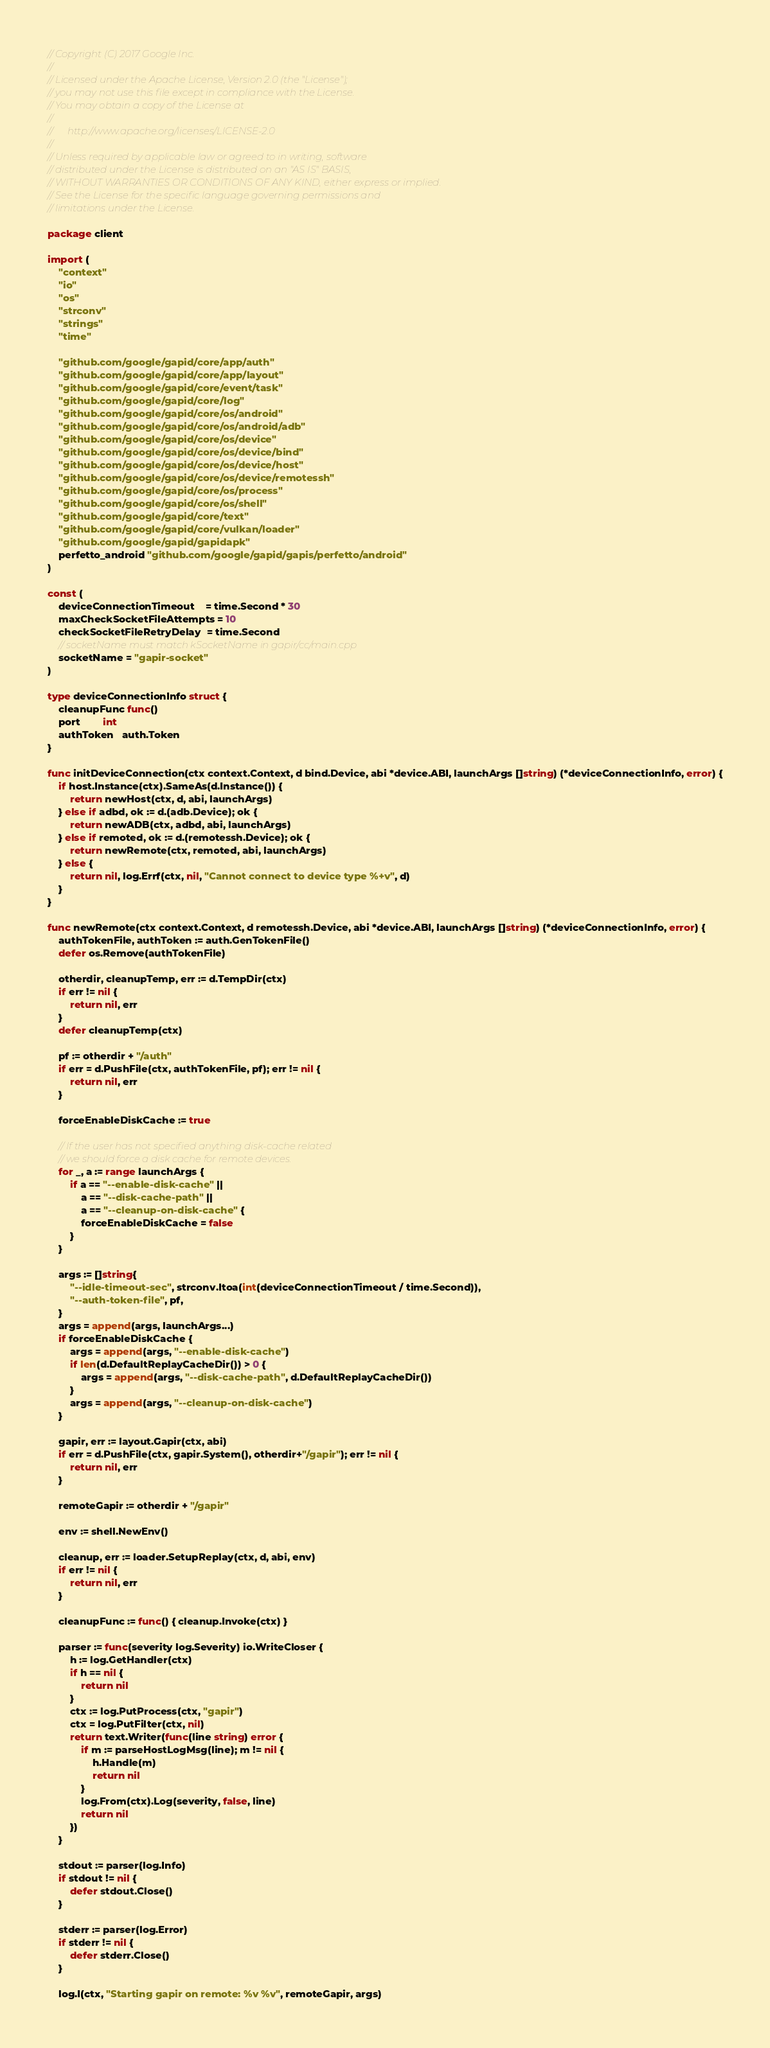<code> <loc_0><loc_0><loc_500><loc_500><_Go_>// Copyright (C) 2017 Google Inc.
//
// Licensed under the Apache License, Version 2.0 (the "License");
// you may not use this file except in compliance with the License.
// You may obtain a copy of the License at
//
//      http://www.apache.org/licenses/LICENSE-2.0
//
// Unless required by applicable law or agreed to in writing, software
// distributed under the License is distributed on an "AS IS" BASIS,
// WITHOUT WARRANTIES OR CONDITIONS OF ANY KIND, either express or implied.
// See the License for the specific language governing permissions and
// limitations under the License.

package client

import (
	"context"
	"io"
	"os"
	"strconv"
	"strings"
	"time"

	"github.com/google/gapid/core/app/auth"
	"github.com/google/gapid/core/app/layout"
	"github.com/google/gapid/core/event/task"
	"github.com/google/gapid/core/log"
	"github.com/google/gapid/core/os/android"
	"github.com/google/gapid/core/os/android/adb"
	"github.com/google/gapid/core/os/device"
	"github.com/google/gapid/core/os/device/bind"
	"github.com/google/gapid/core/os/device/host"
	"github.com/google/gapid/core/os/device/remotessh"
	"github.com/google/gapid/core/os/process"
	"github.com/google/gapid/core/os/shell"
	"github.com/google/gapid/core/text"
	"github.com/google/gapid/core/vulkan/loader"
	"github.com/google/gapid/gapidapk"
	perfetto_android "github.com/google/gapid/gapis/perfetto/android"
)

const (
	deviceConnectionTimeout    = time.Second * 30
	maxCheckSocketFileAttempts = 10
	checkSocketFileRetryDelay  = time.Second
	// socketName must match kSocketName in gapir/cc/main.cpp
	socketName = "gapir-socket"
)

type deviceConnectionInfo struct {
	cleanupFunc func()
	port        int
	authToken   auth.Token
}

func initDeviceConnection(ctx context.Context, d bind.Device, abi *device.ABI, launchArgs []string) (*deviceConnectionInfo, error) {
	if host.Instance(ctx).SameAs(d.Instance()) {
		return newHost(ctx, d, abi, launchArgs)
	} else if adbd, ok := d.(adb.Device); ok {
		return newADB(ctx, adbd, abi, launchArgs)
	} else if remoted, ok := d.(remotessh.Device); ok {
		return newRemote(ctx, remoted, abi, launchArgs)
	} else {
		return nil, log.Errf(ctx, nil, "Cannot connect to device type %+v", d)
	}
}

func newRemote(ctx context.Context, d remotessh.Device, abi *device.ABI, launchArgs []string) (*deviceConnectionInfo, error) {
	authTokenFile, authToken := auth.GenTokenFile()
	defer os.Remove(authTokenFile)

	otherdir, cleanupTemp, err := d.TempDir(ctx)
	if err != nil {
		return nil, err
	}
	defer cleanupTemp(ctx)

	pf := otherdir + "/auth"
	if err = d.PushFile(ctx, authTokenFile, pf); err != nil {
		return nil, err
	}

	forceEnableDiskCache := true

	// If the user has not specified anything disk-cache related
	// we should force a disk cache for remote devices.
	for _, a := range launchArgs {
		if a == "--enable-disk-cache" ||
			a == "--disk-cache-path" ||
			a == "--cleanup-on-disk-cache" {
			forceEnableDiskCache = false
		}
	}

	args := []string{
		"--idle-timeout-sec", strconv.Itoa(int(deviceConnectionTimeout / time.Second)),
		"--auth-token-file", pf,
	}
	args = append(args, launchArgs...)
	if forceEnableDiskCache {
		args = append(args, "--enable-disk-cache")
		if len(d.DefaultReplayCacheDir()) > 0 {
			args = append(args, "--disk-cache-path", d.DefaultReplayCacheDir())
		}
		args = append(args, "--cleanup-on-disk-cache")
	}

	gapir, err := layout.Gapir(ctx, abi)
	if err = d.PushFile(ctx, gapir.System(), otherdir+"/gapir"); err != nil {
		return nil, err
	}

	remoteGapir := otherdir + "/gapir"

	env := shell.NewEnv()

	cleanup, err := loader.SetupReplay(ctx, d, abi, env)
	if err != nil {
		return nil, err
	}

	cleanupFunc := func() { cleanup.Invoke(ctx) }

	parser := func(severity log.Severity) io.WriteCloser {
		h := log.GetHandler(ctx)
		if h == nil {
			return nil
		}
		ctx := log.PutProcess(ctx, "gapir")
		ctx = log.PutFilter(ctx, nil)
		return text.Writer(func(line string) error {
			if m := parseHostLogMsg(line); m != nil {
				h.Handle(m)
				return nil
			}
			log.From(ctx).Log(severity, false, line)
			return nil
		})
	}

	stdout := parser(log.Info)
	if stdout != nil {
		defer stdout.Close()
	}

	stderr := parser(log.Error)
	if stderr != nil {
		defer stderr.Close()
	}

	log.I(ctx, "Starting gapir on remote: %v %v", remoteGapir, args)
</code> 